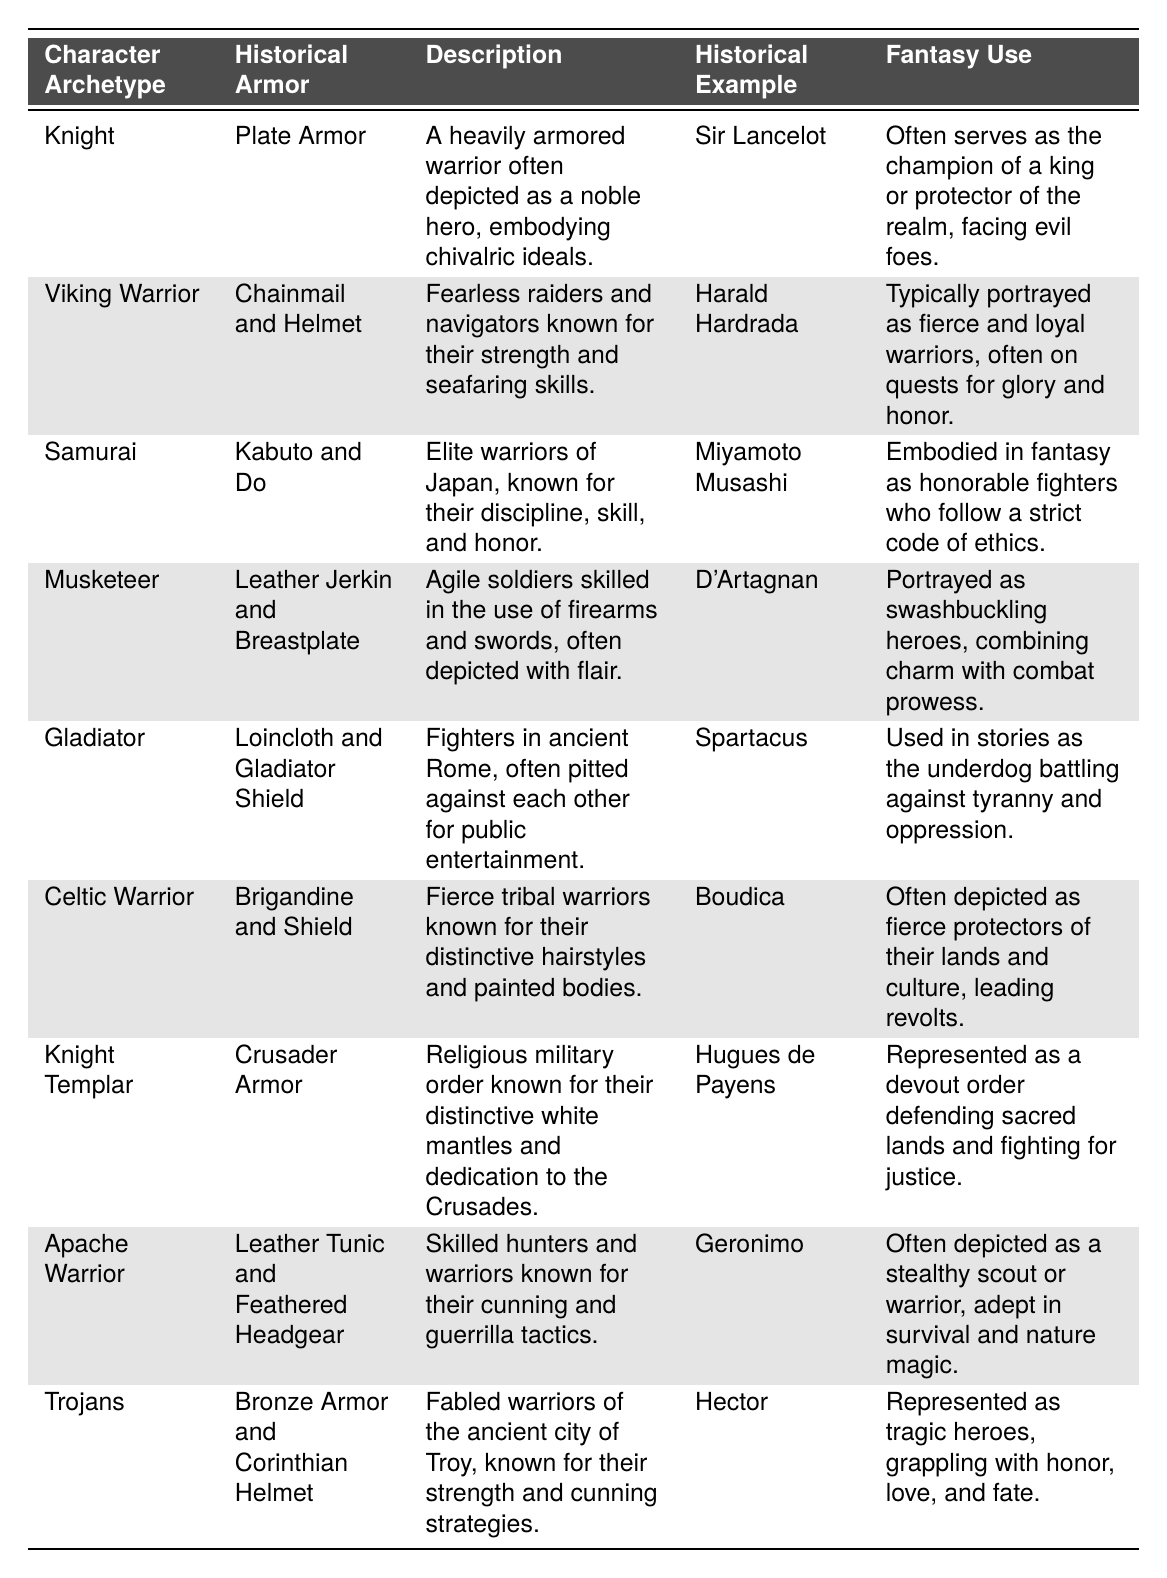What type of armor is associated with the Knight archetype? According to the table, the Knight archetype is associated with Plate Armor.
Answer: Plate Armor Which character archetype is depicted as a protector of the realm? The table states that the Knight archetype often serves as the champion of a king or protector of the realm, implying its role in this context.
Answer: Knight What historical example is given for the Samurai? The table lists Miyamoto Musashi as the historical example of the Samurai archetype.
Answer: Miyamoto Musashi True or False: The Viking Warrior archetype is associated with bronze armor. Referring to the table, the Viking Warrior is associated with Chainmail and Helmet, not bronze armor, making the statement false.
Answer: False Which character archetype is often used as a representation of the underdog? The table indicates that the Gladiator archetype is used in stories as the underdog battling against tyranny and oppression.
Answer: Gladiator What is the fantasy use of the Apollo Warrior archetype? The table does not include an Apollo Warrior archetype, therefore it does not provide any fantasy use related to it.
Answer: Not applicable How many total character archetypes are listed in the table? The table contains a total of 8 character archetypes.
Answer: 8 Which archetype's historical example is linked to the Crusades? The Knight Templar archetype is linked to the Crusades, as stated in the table.
Answer: Knight Templar What distinguishes the Celtic Warrior's attire? The Celtic Warrior is described in the table as wearing a Brigandine and Shield, showcasing their warrior nature.
Answer: Brigandine and Shield List the historical armor associated with the Musketeer. The table shows that the Musketeer is associated with a Leather Jerkin and Breastplate.
Answer: Leather Jerkin and Breastplate Which character archetype represents tragic heroes grappling with honor, love, and fate? The Trojans are represented in this manner according to the table, highlighting their complex narrative.
Answer: Trojans 